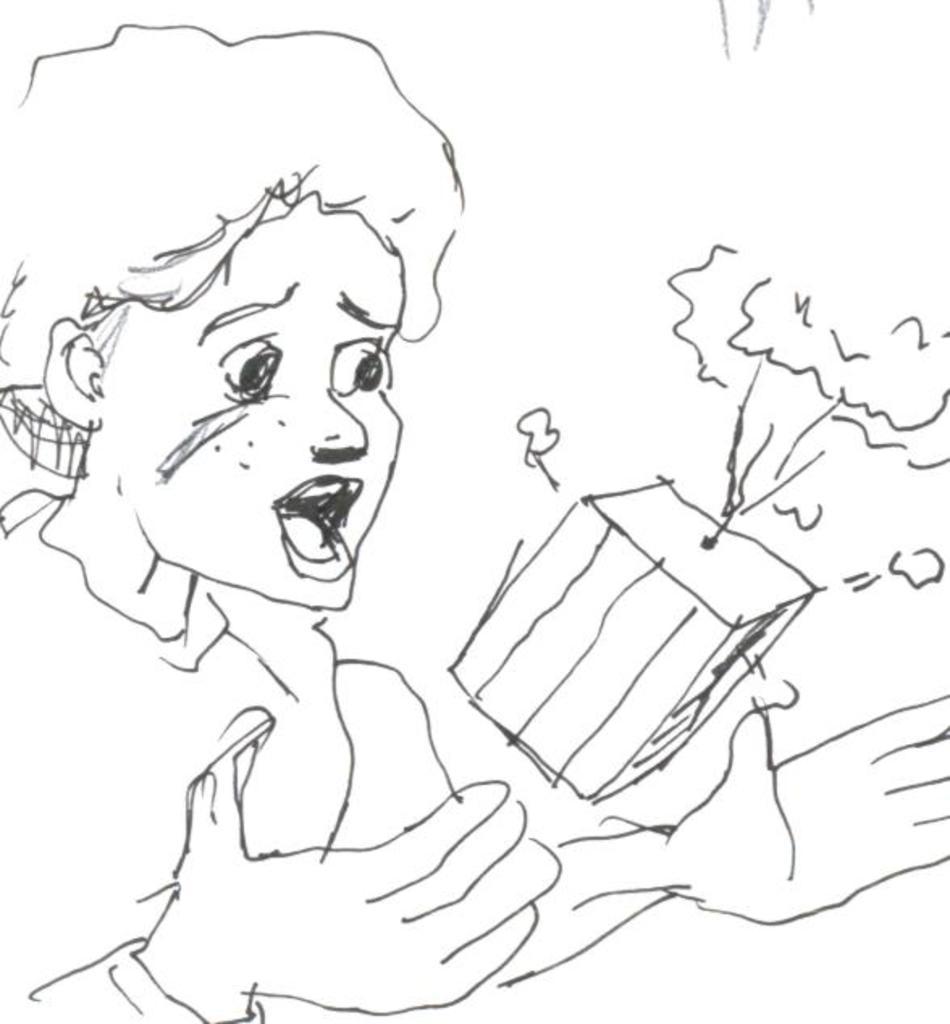Describe this image in one or two sentences. In this image I can see a sketch of a person and a box on the white colored surface. 